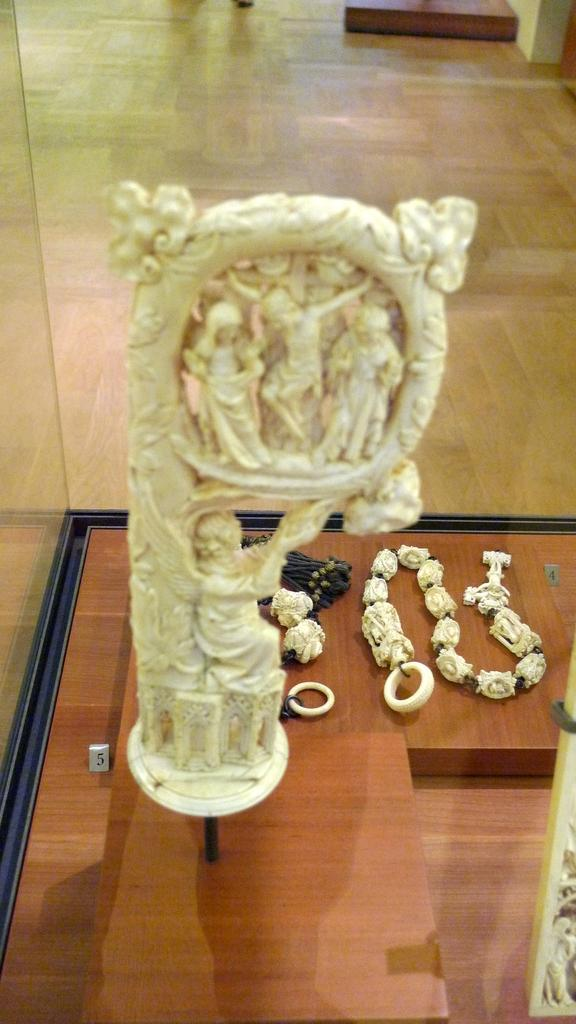What type of art is present in the image? There are sculptures in the image. What is the surface on which the objects are placed? There are objects on a wooden platform in the image. What can be seen in the background of the image? The background of the image includes the floor and glass. What time does the father start his shift in the image? There is no reference to a father or a shift in the image, so it's not possible to answer that question. What type of ornament is hanging from the ceiling in the image? There is no ornament hanging from the ceiling in the image. 